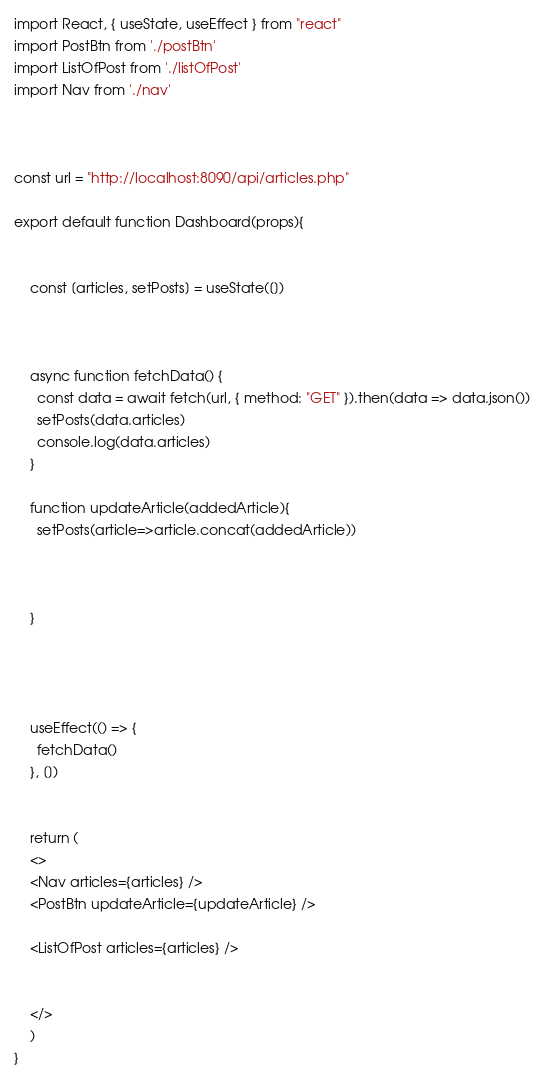<code> <loc_0><loc_0><loc_500><loc_500><_JavaScript_>import React, { useState, useEffect } from "react"
import PostBtn from './postBtn'
import ListOfPost from './listOfPost'
import Nav from './nav'



const url = "http://localhost:8090/api/articles.php"

export default function Dashboard(props){

   
    const [articles, setPosts] = useState([])



    async function fetchData() {
      const data = await fetch(url, { method: "GET" }).then(data => data.json())
      setPosts(data.articles)
      console.log(data.articles)
    }

    function updateArticle(addedArticle){
      setPosts(article=>article.concat(addedArticle))
      


    }  

    
    

    useEffect(() => {
      fetchData()
    }, [])

   
    return (
    <>
    <Nav articles={articles} />
    <PostBtn updateArticle={updateArticle} />
    
    <ListOfPost articles={articles} />
  

    </>
    )
}</code> 